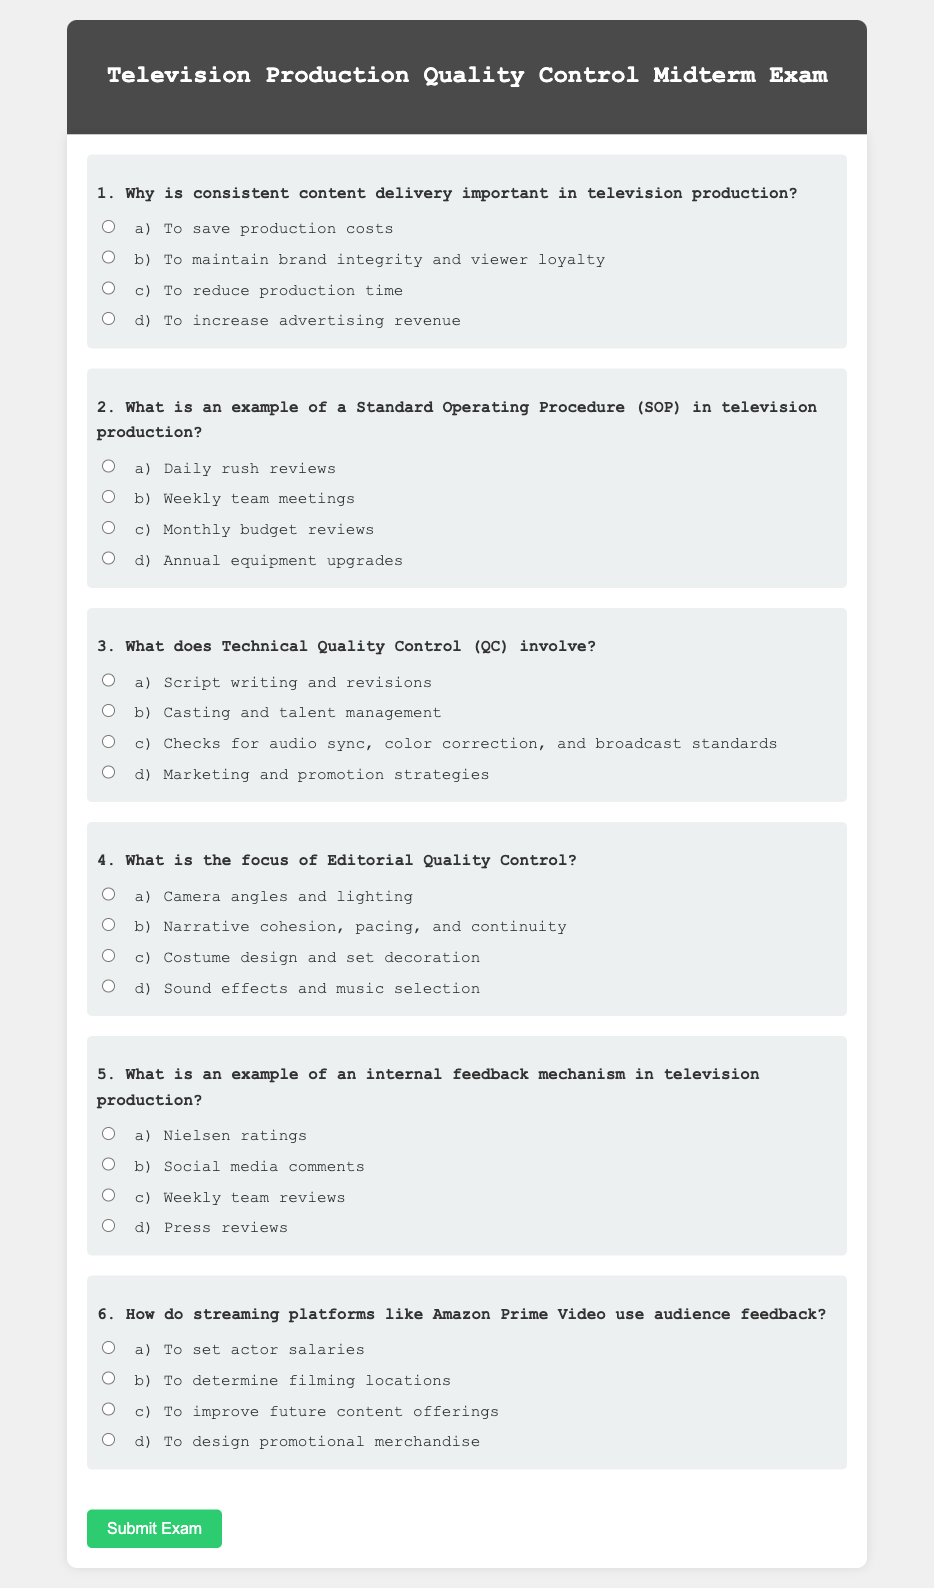What is the main topic of the midterm exam? The main topic of the midterm exam is outlined in the header, mentioning "Quality Control in Television Production."
Answer: Quality Control in Television Production How many questions are included in the exam? The document lists a total of six questions presented in the exam format.
Answer: Six What is the focus of question 4? Question 4 specifically asks about "Editorial Quality Control" in television production.
Answer: Editorial Quality Control Which option is listed as an example of an SOP in question 2? The options provided include "Daily rush reviews," among others, as examples of Standard Operating Procedures.
Answer: Daily rush reviews What type of feedback mechanism is highlighted in question 5? The question focuses on identifying an internal feedback mechanism within television production.
Answer: Weekly team reviews How does question 6 relate to audience feedback? Question 6 addresses how streaming platforms utilize audience feedback to enhance their content.
Answer: Improve future content offerings 